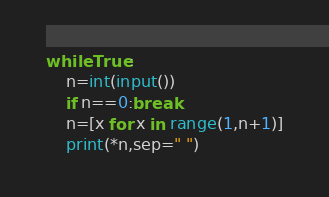Convert code to text. <code><loc_0><loc_0><loc_500><loc_500><_Python_>while True:
    n=int(input())
    if n==0:break
    n=[x for x in range(1,n+1)]
    print(*n,sep=" ")
</code> 